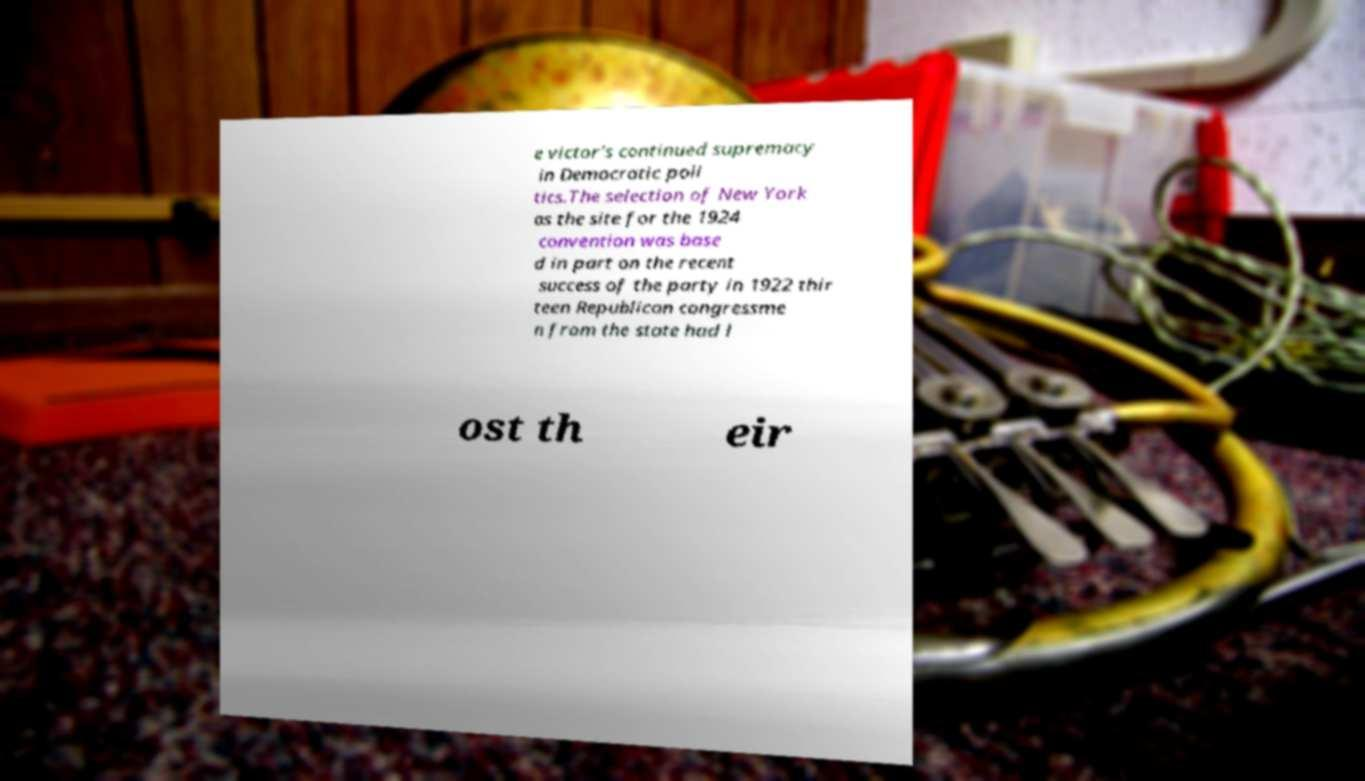Could you assist in decoding the text presented in this image and type it out clearly? e victor's continued supremacy in Democratic poli tics.The selection of New York as the site for the 1924 convention was base d in part on the recent success of the party in 1922 thir teen Republican congressme n from the state had l ost th eir 